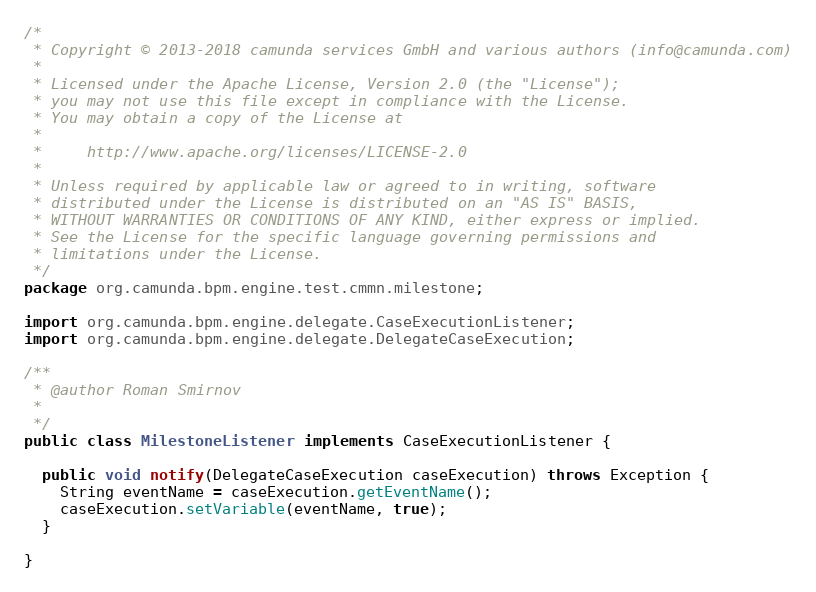<code> <loc_0><loc_0><loc_500><loc_500><_Java_>/*
 * Copyright © 2013-2018 camunda services GmbH and various authors (info@camunda.com)
 *
 * Licensed under the Apache License, Version 2.0 (the "License");
 * you may not use this file except in compliance with the License.
 * You may obtain a copy of the License at
 *
 *     http://www.apache.org/licenses/LICENSE-2.0
 *
 * Unless required by applicable law or agreed to in writing, software
 * distributed under the License is distributed on an "AS IS" BASIS,
 * WITHOUT WARRANTIES OR CONDITIONS OF ANY KIND, either express or implied.
 * See the License for the specific language governing permissions and
 * limitations under the License.
 */
package org.camunda.bpm.engine.test.cmmn.milestone;

import org.camunda.bpm.engine.delegate.CaseExecutionListener;
import org.camunda.bpm.engine.delegate.DelegateCaseExecution;

/**
 * @author Roman Smirnov
 *
 */
public class MilestoneListener implements CaseExecutionListener {

  public void notify(DelegateCaseExecution caseExecution) throws Exception {
    String eventName = caseExecution.getEventName();
    caseExecution.setVariable(eventName, true);
  }

}
</code> 